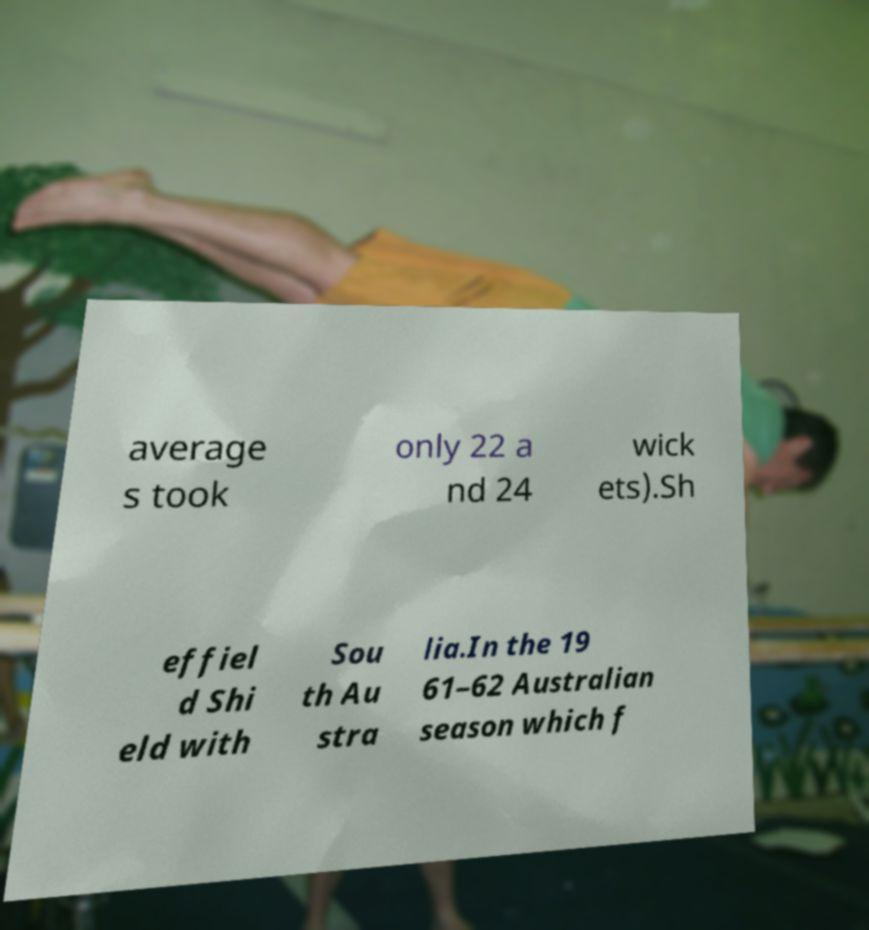Could you extract and type out the text from this image? average s took only 22 a nd 24 wick ets).Sh effiel d Shi eld with Sou th Au stra lia.In the 19 61–62 Australian season which f 